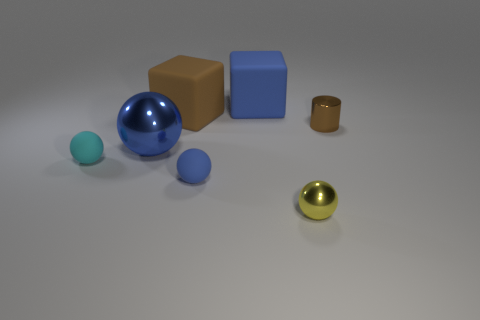There is a ball that is right of the big blue rubber block; what material is it?
Your response must be concise. Metal. There is a large blue thing that is the same shape as the yellow metallic object; what material is it?
Offer a terse response. Metal. There is a large blue block to the left of the cylinder; is there a cyan sphere that is behind it?
Your answer should be compact. No. Is the shape of the large brown object the same as the small blue matte object?
Ensure brevity in your answer.  No. What is the shape of the other small thing that is made of the same material as the cyan object?
Your response must be concise. Sphere. There is a metallic ball that is in front of the big blue metal object; is its size the same as the metal sphere left of the tiny yellow thing?
Offer a very short reply. No. Is the number of small rubber balls that are behind the cyan rubber sphere greater than the number of small balls behind the brown metal thing?
Keep it short and to the point. No. How many other objects are there of the same color as the large metallic ball?
Give a very brief answer. 2. There is a tiny metal cylinder; is its color the same as the cube left of the big blue block?
Ensure brevity in your answer.  Yes. There is a thing that is behind the brown rubber block; how many metal balls are on the left side of it?
Ensure brevity in your answer.  1. 